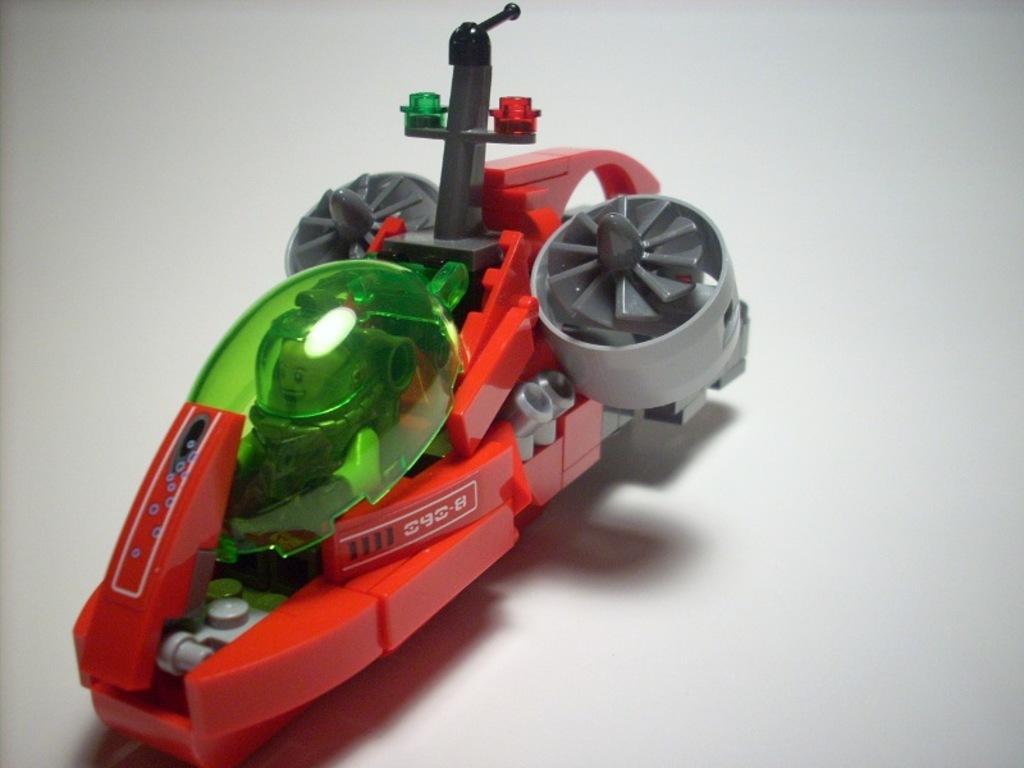In one or two sentences, can you explain what this image depicts? In this image, we can see a red toy on the white surface. 